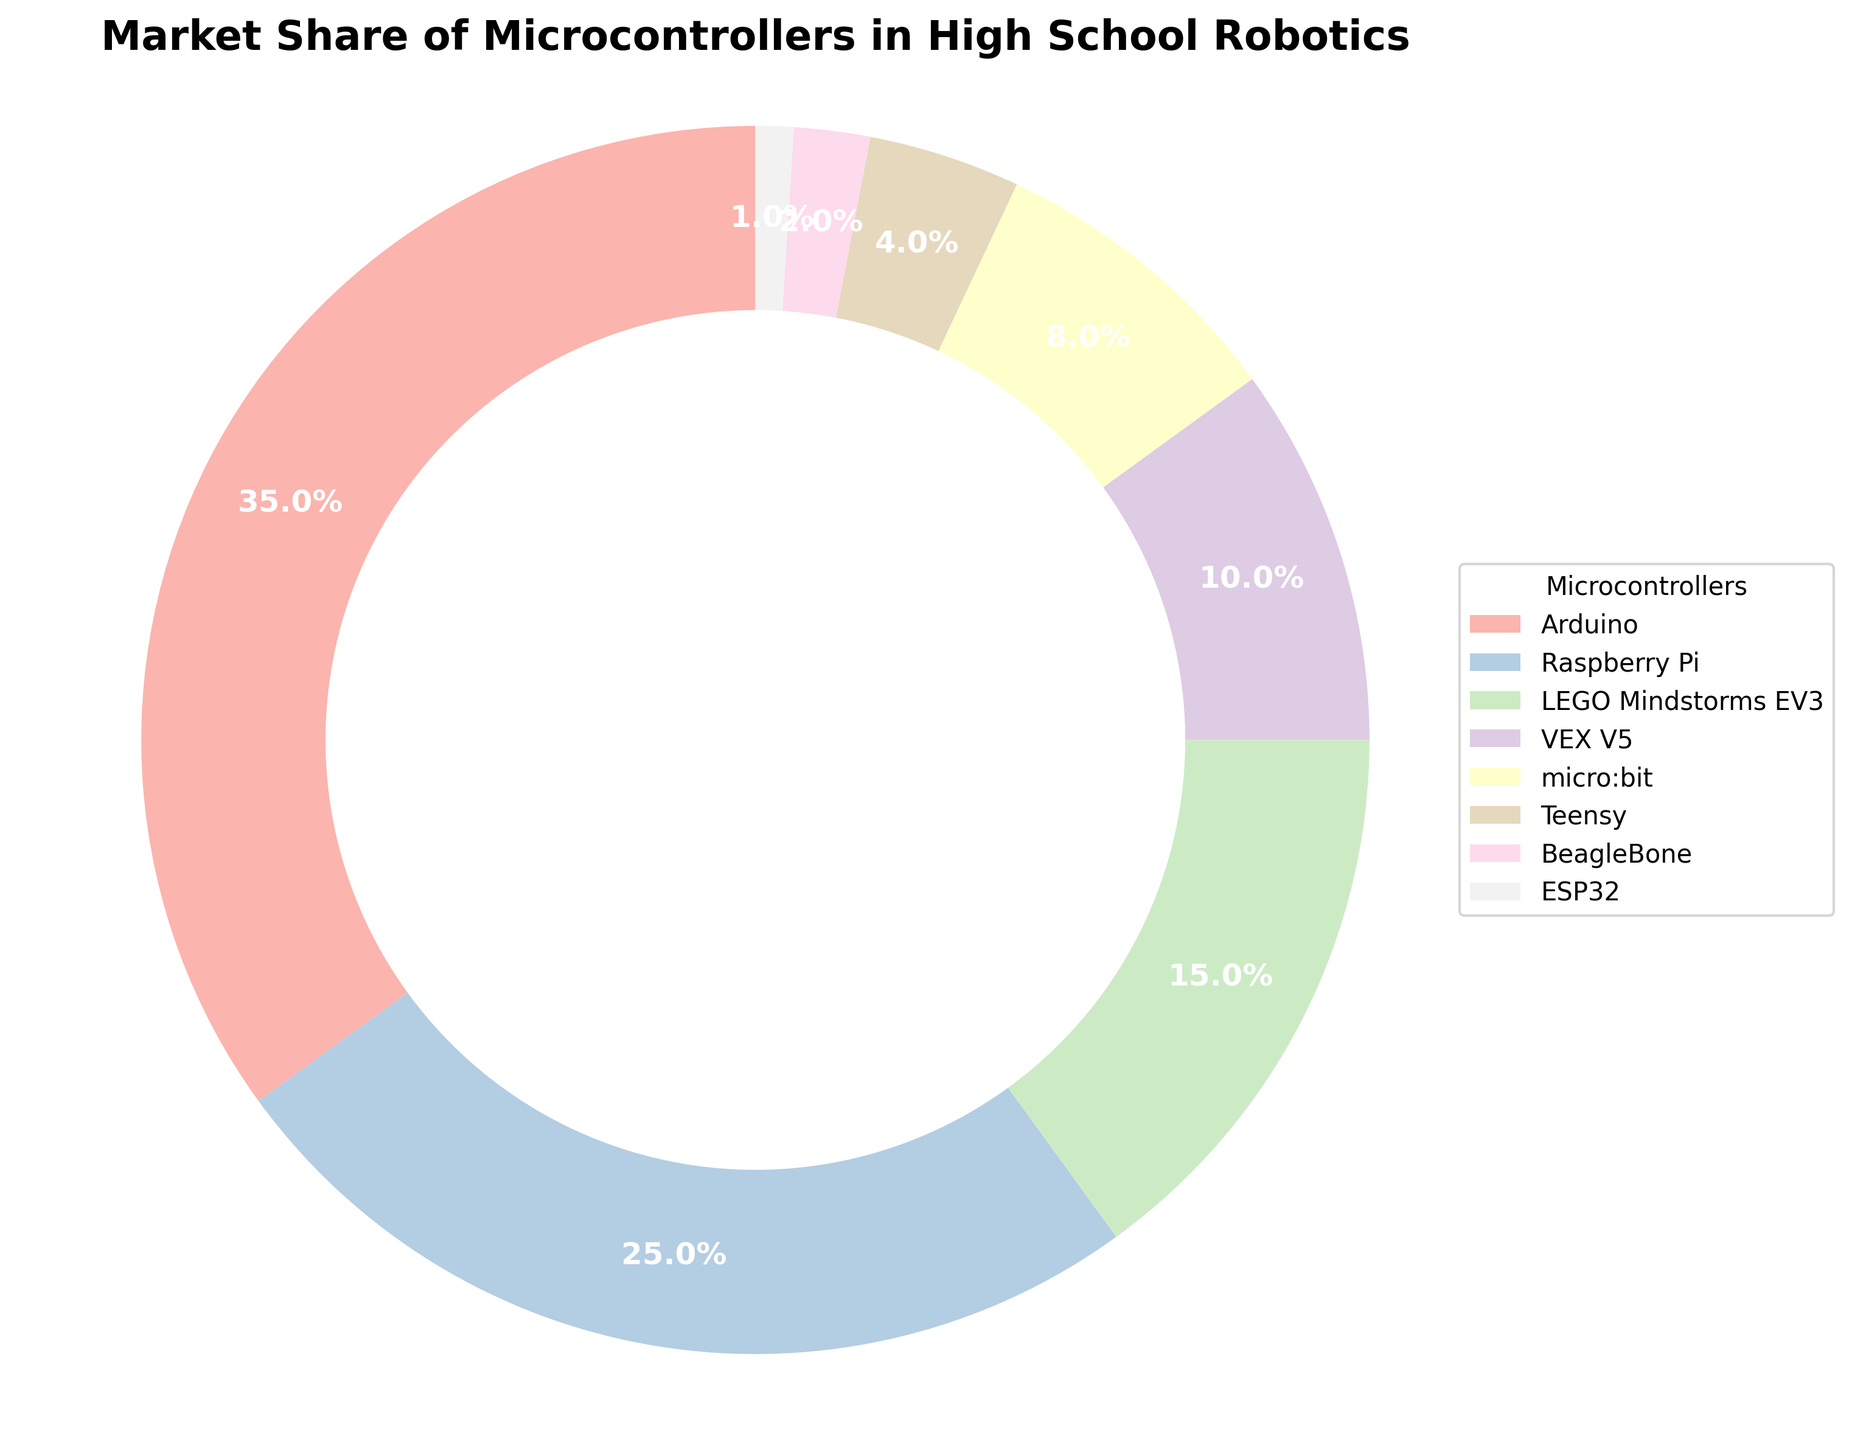What's the largest market share percentage shown in the chart? The largest segment in the pie chart can be identified as the Arduino, which takes a substantial part of the chart. The percentage labeled on the Arduino segment is 35%.
Answer: 35% Which microcontroller has the smallest market share? The smallest segment in the pie chart can be identified as the ESP32, which takes the least space. The percentage labeled on the ESP32 segment is 1%.
Answer: ESP32 What is the combined market share of Raspberry Pi and LEGO Mindstorms EV3? To find the combined market share, locate the Raspberry Pi and LEGO Mindstorms EV3 segments on the chart. Raspberry Pi has a 25% market share, and LEGO Mindstorms EV3 has 15%. Adding these together gives 25% + 15% = 40%.
Answer: 40% How much greater is the market share of Arduino compared to VEX V5? Identify the market share percentages from the chart: Arduino has 35%, and VEX V5 has 10%. Subtract VEX V5's share from Arduino's share: 35% - 10% = 25%.
Answer: 25% Which microcontroller represents half of the total market share of Raspberry Pi? Half of the Raspberry Pi’s market share (25%) is calculated as 25% / 2 = 12.5%. Locate the microcontroller closest to this value on the chart, which is micro:bit with an 8% share.
Answer: micro:bit Which two microcontrollers together have a larger market share than Arduino? Arduino has a 35% market share. Locate two segments that collectively exceed this value. Raspberry Pi and LEGO Mindstorms EV3 together have 25% + 15% = 40%, which is greater than 35%.
Answer: Raspberry Pi and LEGO Mindstorms EV3 Which microcontroller has roughly one-quarter of the total market share of Arduino? A quarter of Arduino's market share (35%) is calculated as 35% / 4 = 8.75%. The microcontroller closest to this value is micro:bit with an 8% market share.
Answer: micro:bit Which microcontroller's segment is visually the second largest in the pie chart? Identify the segments by size visually. Arduino is the largest, followed by Raspberry Pi, which occupies the second largest area.
Answer: Raspberry Pi How much greater is the combined market share of micro:bit and Teensy compared to BeagleBone? micro:bit has 8% and Teensy has 4%, so their combined market share is 8% + 4% = 12%. BeagleBone has a 2% market share. The difference is 12% - 2% = 10%.
Answer: 10% 